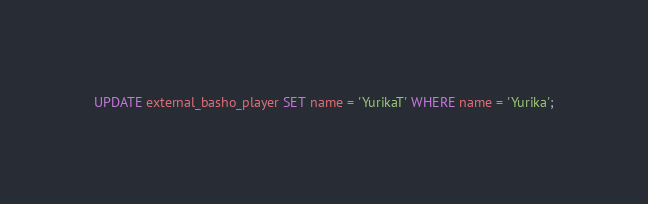<code> <loc_0><loc_0><loc_500><loc_500><_SQL_>UPDATE external_basho_player SET name = 'YurikaT' WHERE name = 'Yurika';</code> 